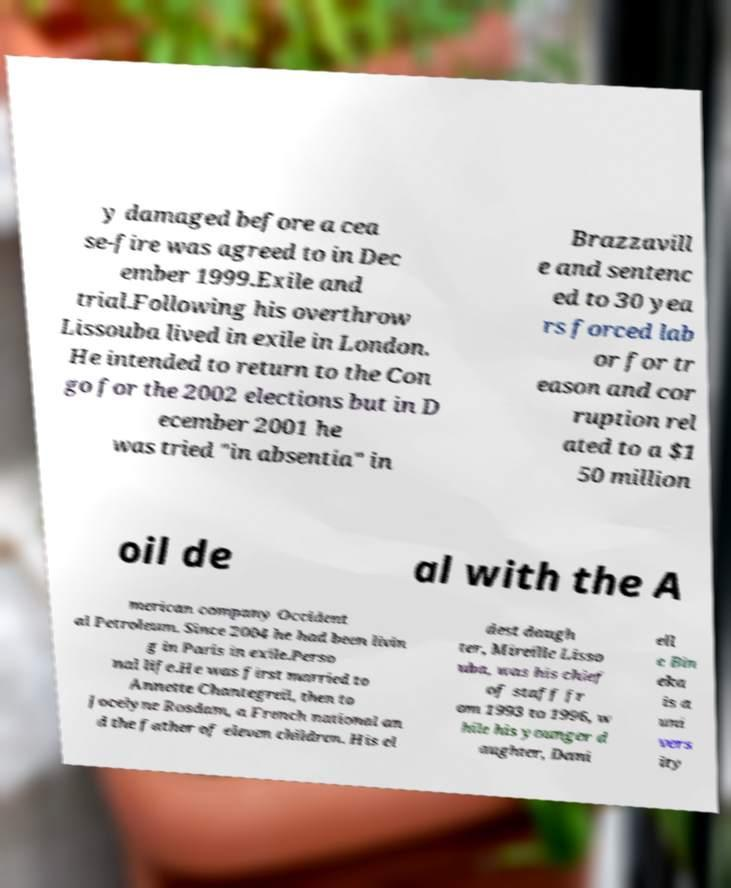Please identify and transcribe the text found in this image. y damaged before a cea se-fire was agreed to in Dec ember 1999.Exile and trial.Following his overthrow Lissouba lived in exile in London. He intended to return to the Con go for the 2002 elections but in D ecember 2001 he was tried "in absentia" in Brazzavill e and sentenc ed to 30 yea rs forced lab or for tr eason and cor ruption rel ated to a $1 50 million oil de al with the A merican company Occident al Petroleum. Since 2004 he had been livin g in Paris in exile.Perso nal life.He was first married to Annette Chantegreil, then to Jocelyne Rosdam, a French national an d the father of eleven children. His el dest daugh ter, Mireille Lisso uba, was his chief of staff fr om 1993 to 1996, w hile his younger d aughter, Dani ell e Bin eka is a uni vers ity 